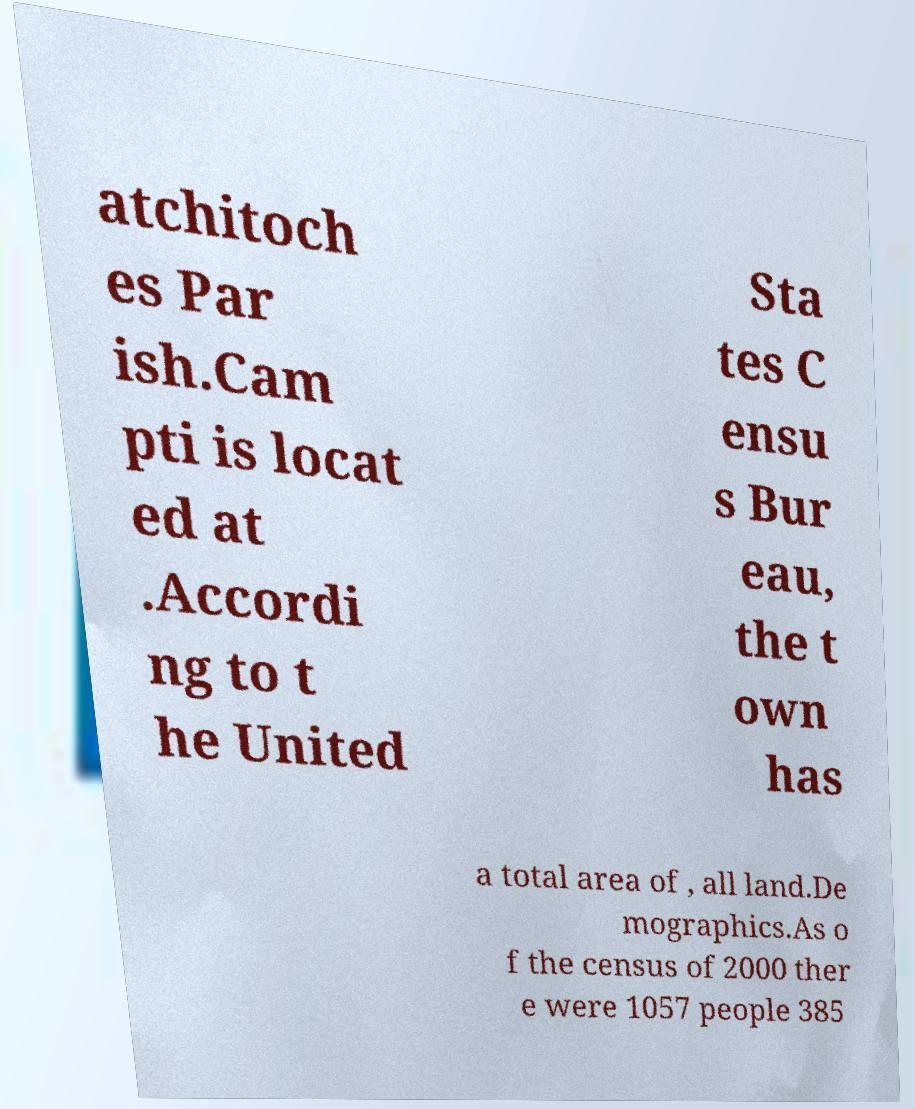Please identify and transcribe the text found in this image. atchitoch es Par ish.Cam pti is locat ed at .Accordi ng to t he United Sta tes C ensu s Bur eau, the t own has a total area of , all land.De mographics.As o f the census of 2000 ther e were 1057 people 385 